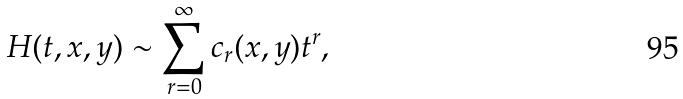Convert formula to latex. <formula><loc_0><loc_0><loc_500><loc_500>H ( t , x , y ) \sim \sum _ { r = 0 } ^ { \infty } c _ { r } ( x , y ) t ^ { r } ,</formula> 